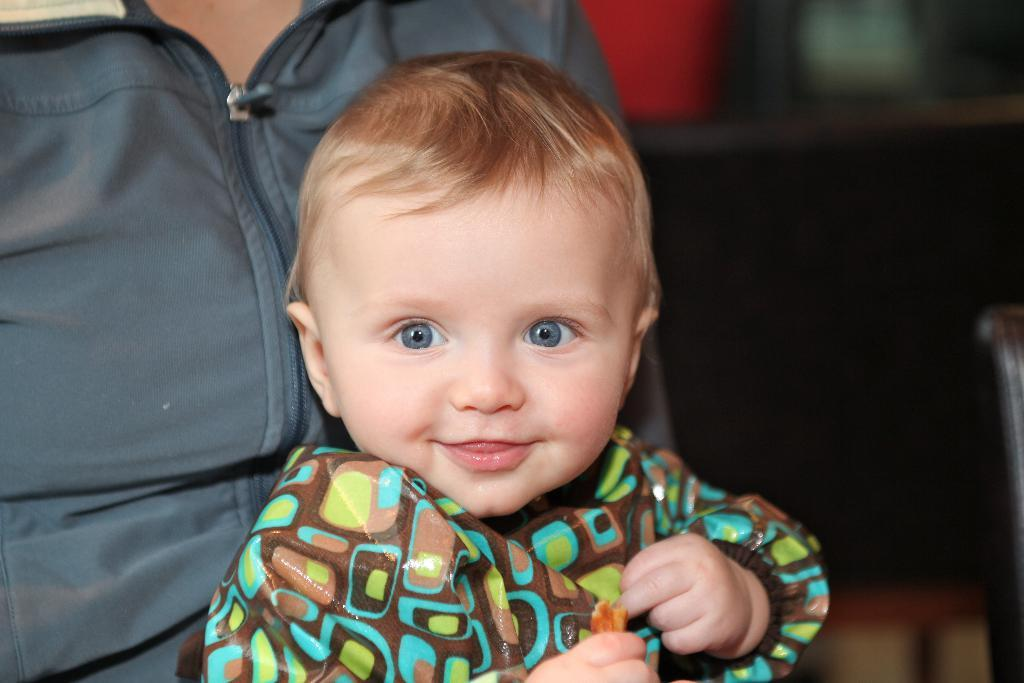Who is present in the image? There is a person in the image. What is the person doing in the image? The person is holding a baby. How does the baby appear to be feeling in the image? The baby is laughing. Can you describe the background of the image? The background of the image is blurry. How many cakes are being tested by the person in the image? There is no mention of cakes or testing in the image; it features a person holding a laughing baby with a blurry background. 